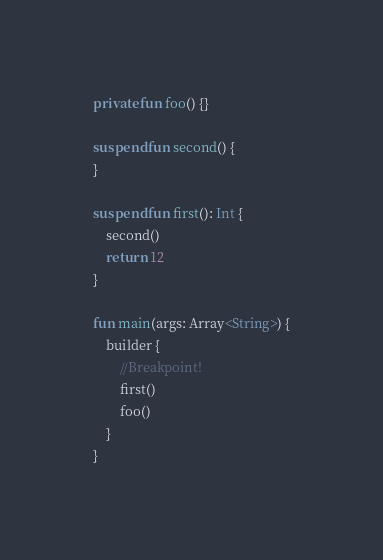Convert code to text. <code><loc_0><loc_0><loc_500><loc_500><_Kotlin_>private fun foo() {}

suspend fun second() {
}

suspend fun first(): Int {
    second()
    return 12
}

fun main(args: Array<String>) {
    builder {
        //Breakpoint!
        first()
        foo()
    }
}</code> 